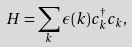<formula> <loc_0><loc_0><loc_500><loc_500>H = \sum _ { k } \epsilon ( k ) c ^ { \dagger } _ { k } c _ { k } ,</formula> 